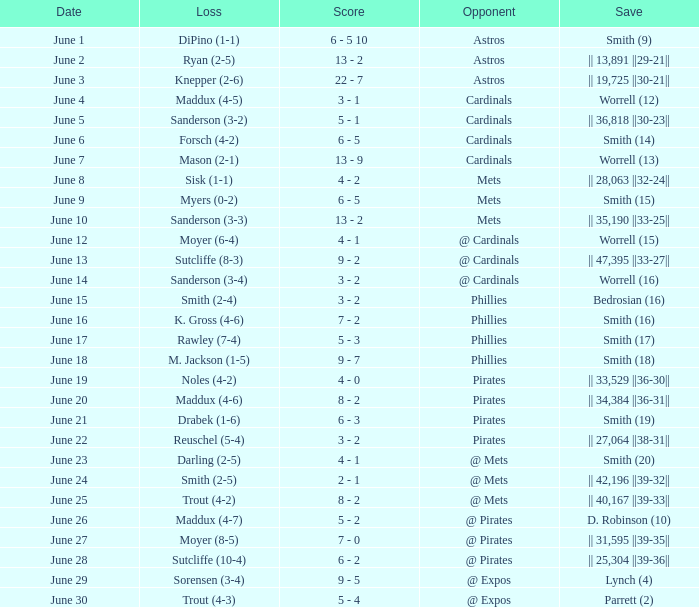What is the date for the game that included a loss of sutcliffe (10-4)? June 28. Can you give me this table as a dict? {'header': ['Date', 'Loss', 'Score', 'Opponent', 'Save'], 'rows': [['June 1', 'DiPino (1-1)', '6 - 5 10', 'Astros', 'Smith (9)'], ['June 2', 'Ryan (2-5)', '13 - 2', 'Astros', '|| 13,891 ||29-21||'], ['June 3', 'Knepper (2-6)', '22 - 7', 'Astros', '|| 19,725 ||30-21||'], ['June 4', 'Maddux (4-5)', '3 - 1', 'Cardinals', 'Worrell (12)'], ['June 5', 'Sanderson (3-2)', '5 - 1', 'Cardinals', '|| 36,818 ||30-23||'], ['June 6', 'Forsch (4-2)', '6 - 5', 'Cardinals', 'Smith (14)'], ['June 7', 'Mason (2-1)', '13 - 9', 'Cardinals', 'Worrell (13)'], ['June 8', 'Sisk (1-1)', '4 - 2', 'Mets', '|| 28,063 ||32-24||'], ['June 9', 'Myers (0-2)', '6 - 5', 'Mets', 'Smith (15)'], ['June 10', 'Sanderson (3-3)', '13 - 2', 'Mets', '|| 35,190 ||33-25||'], ['June 12', 'Moyer (6-4)', '4 - 1', '@ Cardinals', 'Worrell (15)'], ['June 13', 'Sutcliffe (8-3)', '9 - 2', '@ Cardinals', '|| 47,395 ||33-27||'], ['June 14', 'Sanderson (3-4)', '3 - 2', '@ Cardinals', 'Worrell (16)'], ['June 15', 'Smith (2-4)', '3 - 2', 'Phillies', 'Bedrosian (16)'], ['June 16', 'K. Gross (4-6)', '7 - 2', 'Phillies', 'Smith (16)'], ['June 17', 'Rawley (7-4)', '5 - 3', 'Phillies', 'Smith (17)'], ['June 18', 'M. Jackson (1-5)', '9 - 7', 'Phillies', 'Smith (18)'], ['June 19', 'Noles (4-2)', '4 - 0', 'Pirates', '|| 33,529 ||36-30||'], ['June 20', 'Maddux (4-6)', '8 - 2', 'Pirates', '|| 34,384 ||36-31||'], ['June 21', 'Drabek (1-6)', '6 - 3', 'Pirates', 'Smith (19)'], ['June 22', 'Reuschel (5-4)', '3 - 2', 'Pirates', '|| 27,064 ||38-31||'], ['June 23', 'Darling (2-5)', '4 - 1', '@ Mets', 'Smith (20)'], ['June 24', 'Smith (2-5)', '2 - 1', '@ Mets', '|| 42,196 ||39-32||'], ['June 25', 'Trout (4-2)', '8 - 2', '@ Mets', '|| 40,167 ||39-33||'], ['June 26', 'Maddux (4-7)', '5 - 2', '@ Pirates', 'D. Robinson (10)'], ['June 27', 'Moyer (8-5)', '7 - 0', '@ Pirates', '|| 31,595 ||39-35||'], ['June 28', 'Sutcliffe (10-4)', '6 - 2', '@ Pirates', '|| 25,304 ||39-36||'], ['June 29', 'Sorensen (3-4)', '9 - 5', '@ Expos', 'Lynch (4)'], ['June 30', 'Trout (4-3)', '5 - 4', '@ Expos', 'Parrett (2)']]} 